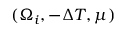Convert formula to latex. <formula><loc_0><loc_0><loc_500><loc_500>( \Omega _ { i } , - \Delta T , \mu )</formula> 